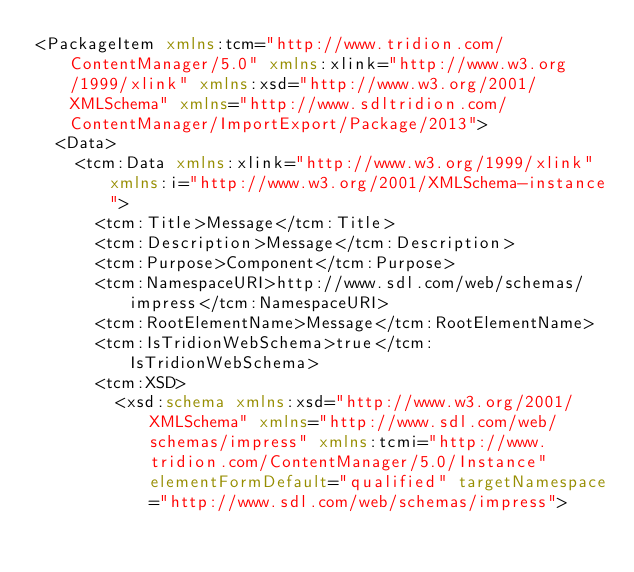Convert code to text. <code><loc_0><loc_0><loc_500><loc_500><_XML_><PackageItem xmlns:tcm="http://www.tridion.com/ContentManager/5.0" xmlns:xlink="http://www.w3.org/1999/xlink" xmlns:xsd="http://www.w3.org/2001/XMLSchema" xmlns="http://www.sdltridion.com/ContentManager/ImportExport/Package/2013">
  <Data>
    <tcm:Data xmlns:xlink="http://www.w3.org/1999/xlink" xmlns:i="http://www.w3.org/2001/XMLSchema-instance">
      <tcm:Title>Message</tcm:Title>
      <tcm:Description>Message</tcm:Description>
      <tcm:Purpose>Component</tcm:Purpose>
      <tcm:NamespaceURI>http://www.sdl.com/web/schemas/impress</tcm:NamespaceURI>
      <tcm:RootElementName>Message</tcm:RootElementName>
      <tcm:IsTridionWebSchema>true</tcm:IsTridionWebSchema>
      <tcm:XSD>
        <xsd:schema xmlns:xsd="http://www.w3.org/2001/XMLSchema" xmlns="http://www.sdl.com/web/schemas/impress" xmlns:tcmi="http://www.tridion.com/ContentManager/5.0/Instance" elementFormDefault="qualified" targetNamespace="http://www.sdl.com/web/schemas/impress"></code> 